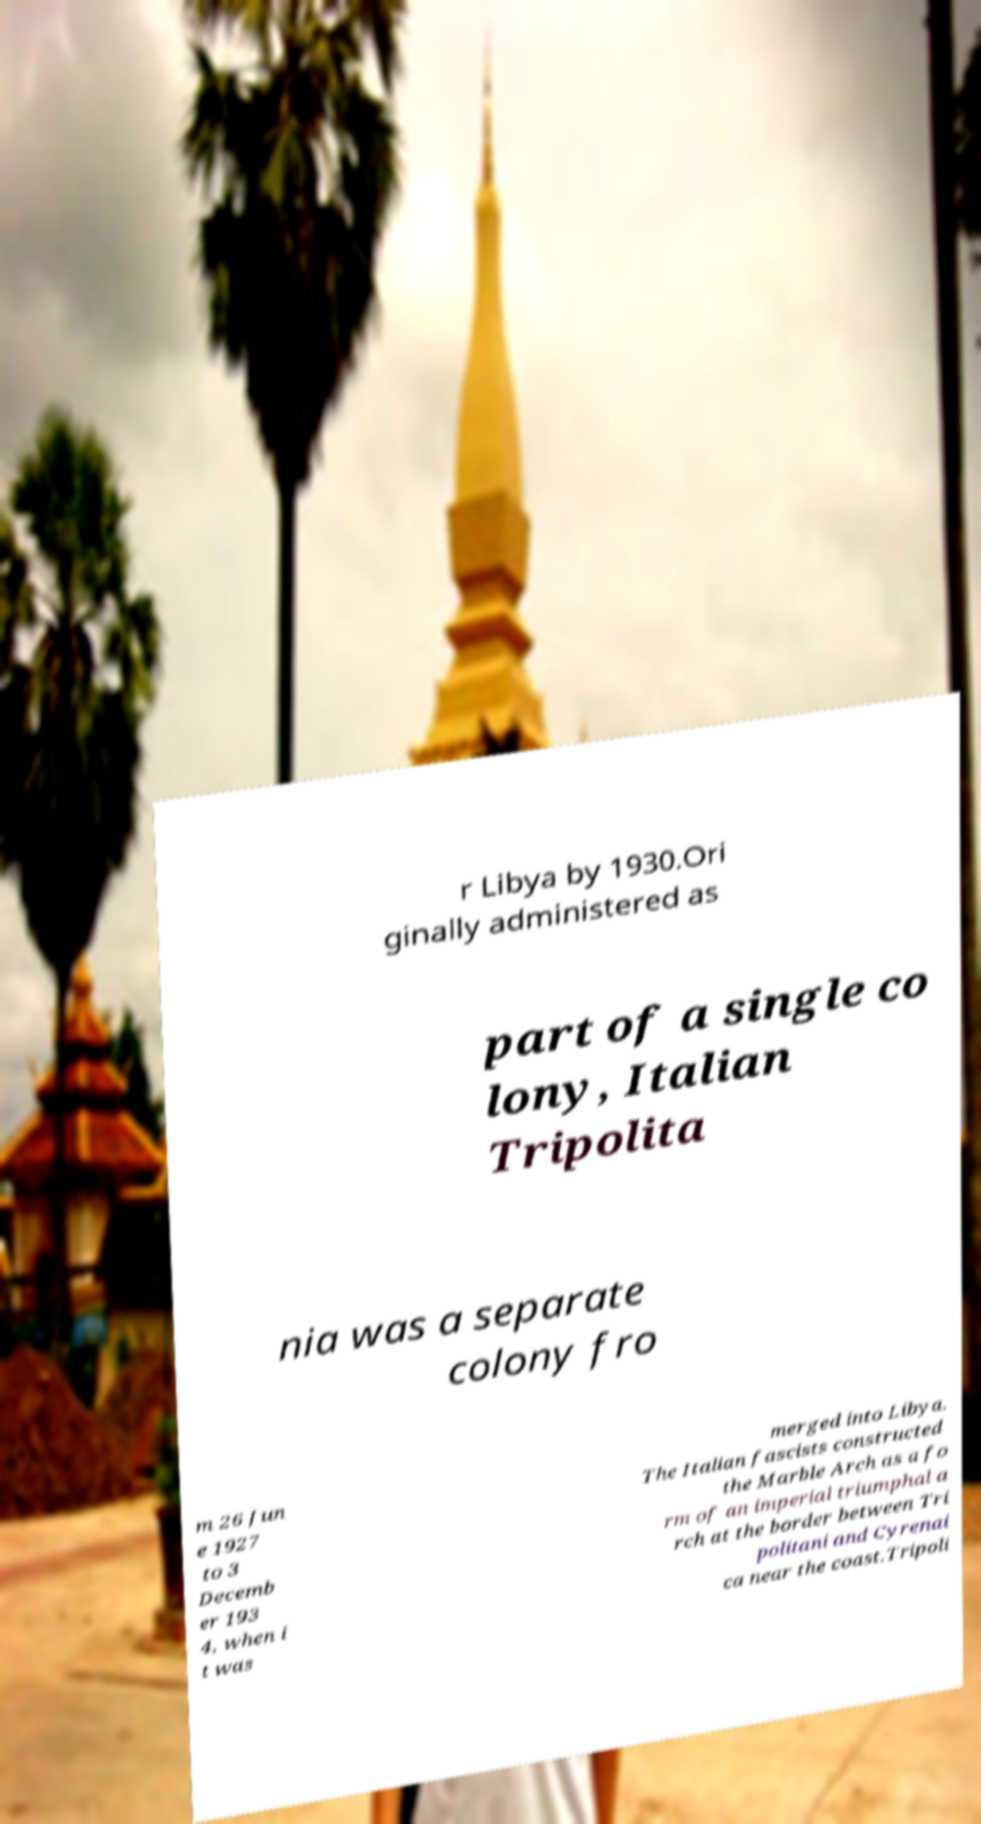For documentation purposes, I need the text within this image transcribed. Could you provide that? r Libya by 1930.Ori ginally administered as part of a single co lony, Italian Tripolita nia was a separate colony fro m 26 Jun e 1927 to 3 Decemb er 193 4, when i t was merged into Libya. The Italian fascists constructed the Marble Arch as a fo rm of an imperial triumphal a rch at the border between Tri politani and Cyrenai ca near the coast.Tripoli 